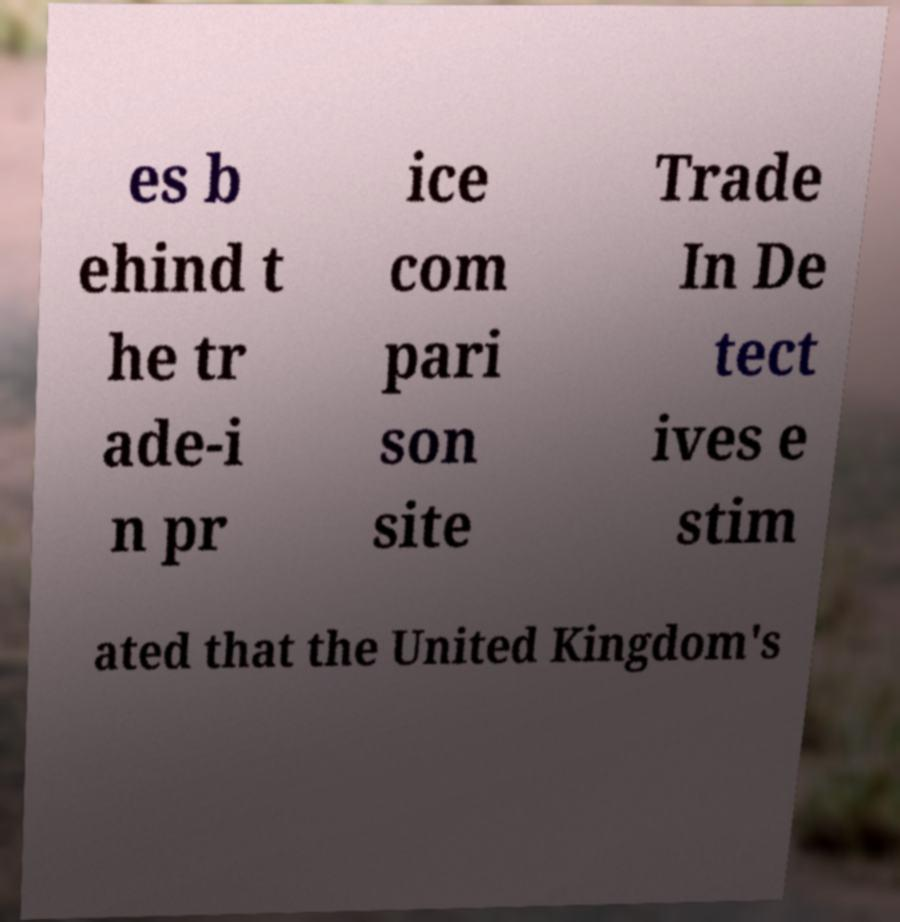Please read and relay the text visible in this image. What does it say? es b ehind t he tr ade-i n pr ice com pari son site Trade In De tect ives e stim ated that the United Kingdom's 